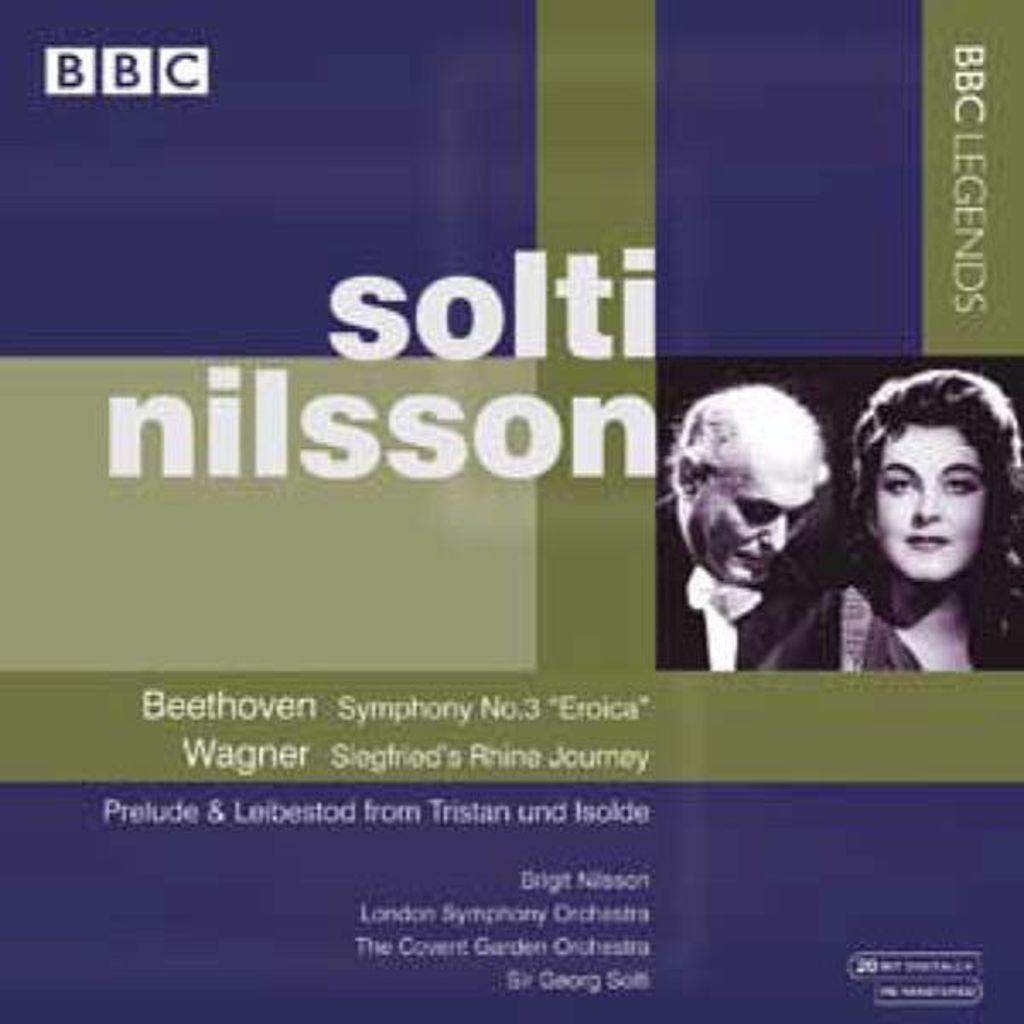Please provide a concise description of this image. In the image in the center, we can see one poster. On the poster we can see two persons. And we can see something written on the poster. 